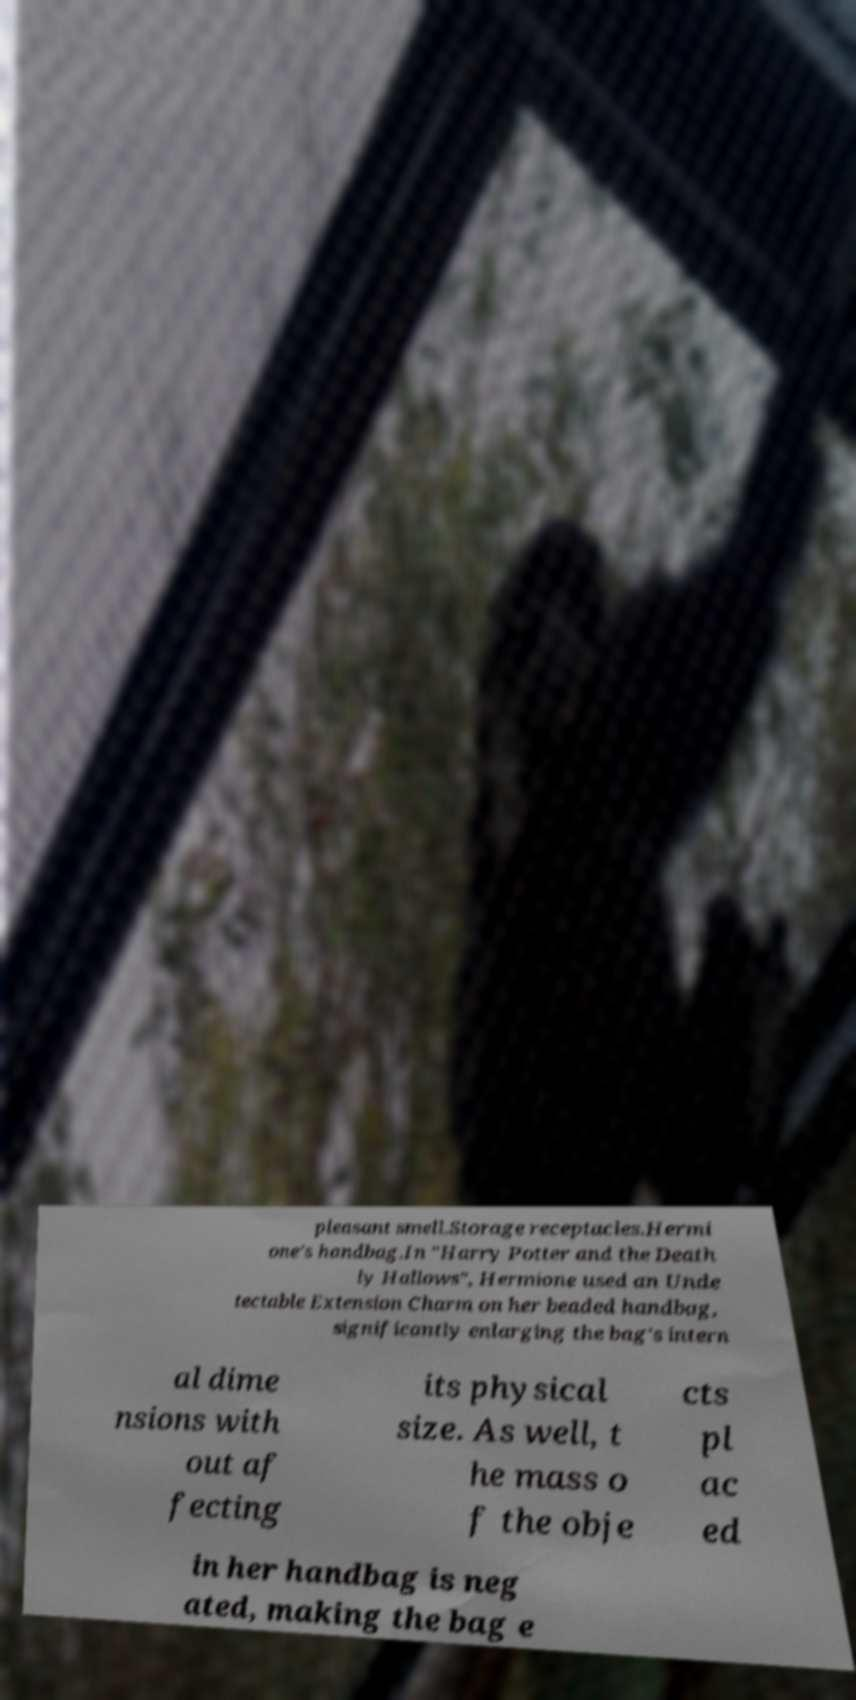Could you assist in decoding the text presented in this image and type it out clearly? pleasant smell.Storage receptacles.Hermi one's handbag.In "Harry Potter and the Death ly Hallows", Hermione used an Unde tectable Extension Charm on her beaded handbag, significantly enlarging the bag's intern al dime nsions with out af fecting its physical size. As well, t he mass o f the obje cts pl ac ed in her handbag is neg ated, making the bag e 